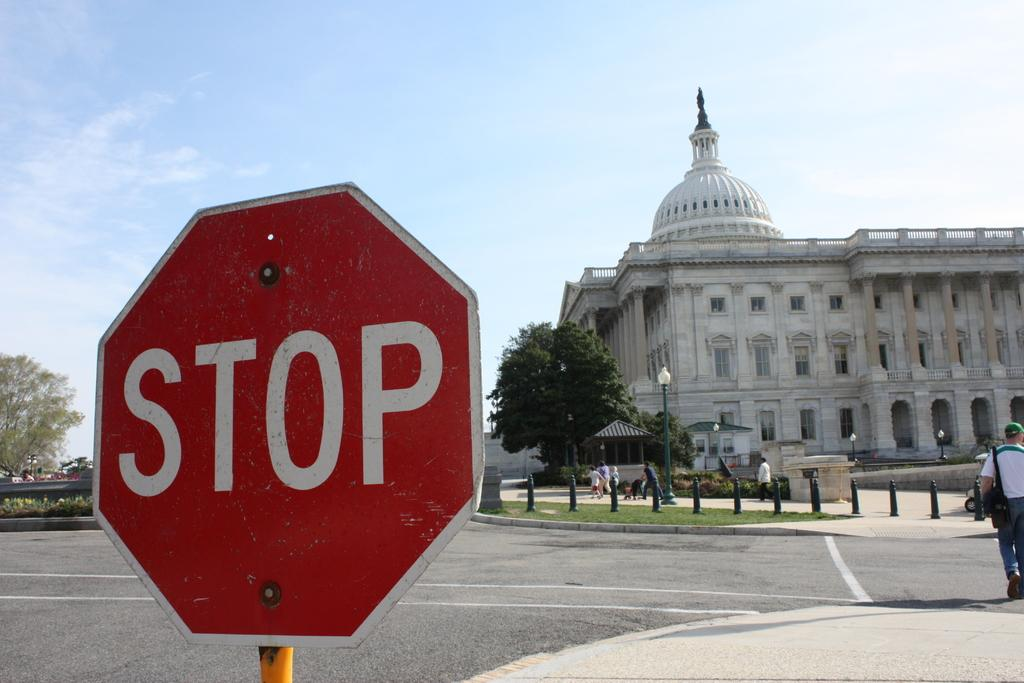<image>
Summarize the visual content of the image. A stop sign is on a street near a large building in the background. 